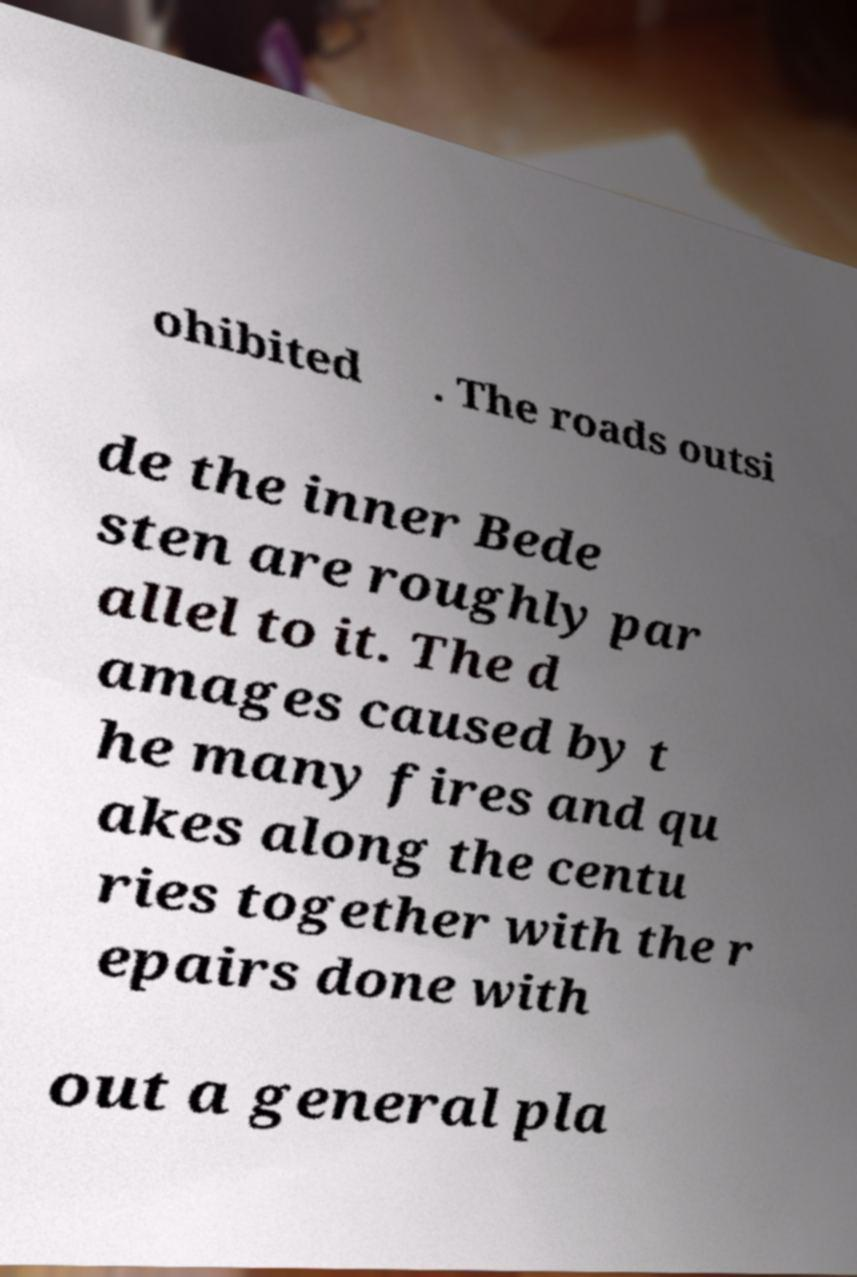There's text embedded in this image that I need extracted. Can you transcribe it verbatim? ohibited . The roads outsi de the inner Bede sten are roughly par allel to it. The d amages caused by t he many fires and qu akes along the centu ries together with the r epairs done with out a general pla 